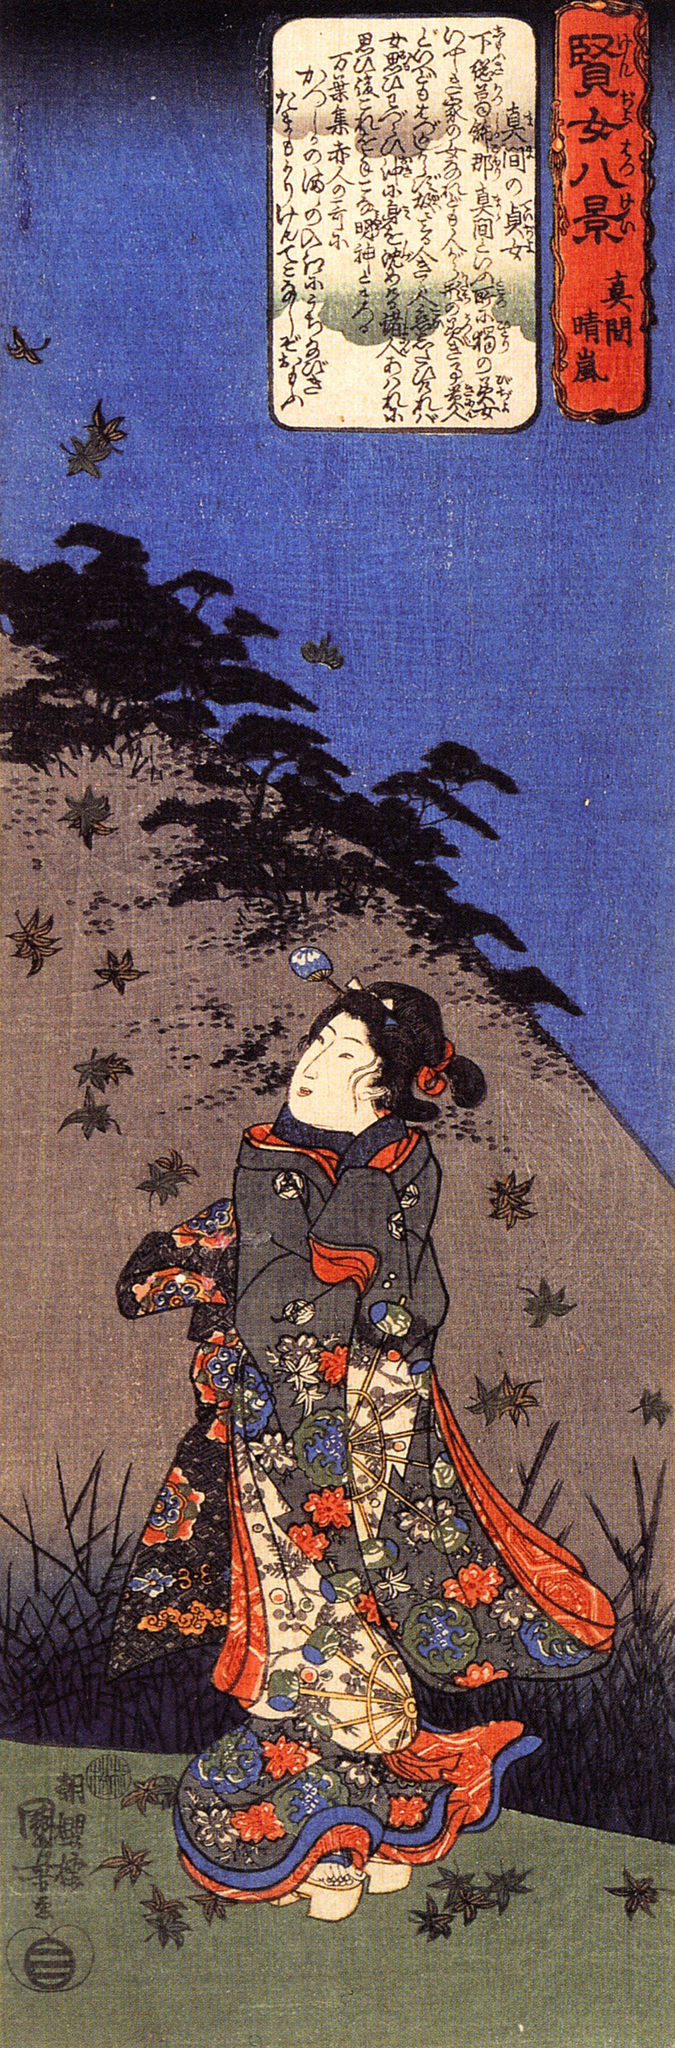Imagine yourself as the woman in the kimono. What are your thoughts and feelings as you look up at the sky? Standing on the lush grass, wrapped in the vibrant embrace of my kimono, I feel the weight of history and tradition on my shoulders, yet an overwhelming sense of serenity washes over me. As I gaze upwards, the sky’s infinite expanse fills me with awe and wonder. The birds, in their graceful flight, represent freedom and the endless possibilities that lie ahead. I am drawn to them, their effortless movement a reminder of the dream-like quality of life. My heart swells with a mix of nostalgia for the beauty of my heritage and hope for the journey that awaits. In this moment, I am at peace, feeling a deep connection with the world around me and a profound gratitude for its enduring beauty. 